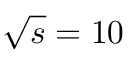<formula> <loc_0><loc_0><loc_500><loc_500>\sqrt { s } = 1 0</formula> 